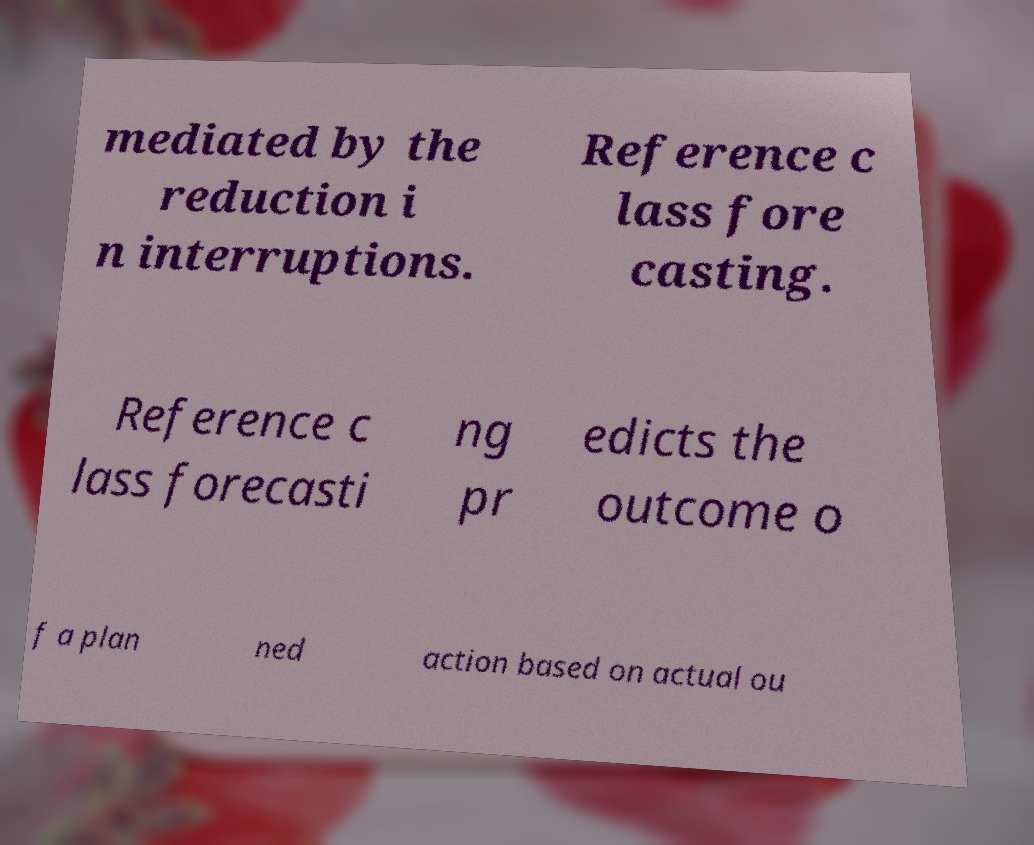Please identify and transcribe the text found in this image. mediated by the reduction i n interruptions. Reference c lass fore casting. Reference c lass forecasti ng pr edicts the outcome o f a plan ned action based on actual ou 